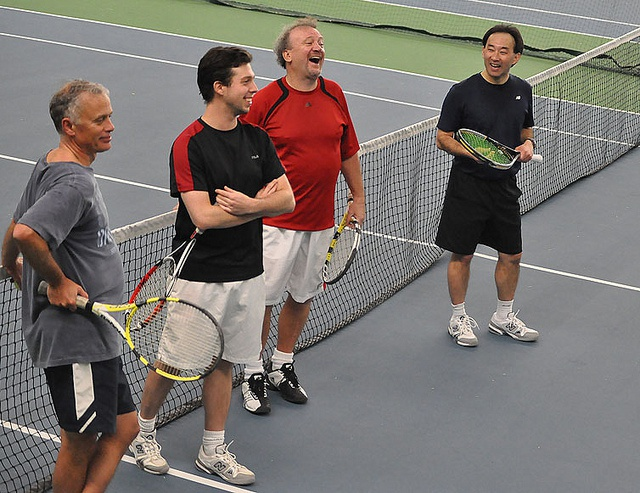Describe the objects in this image and their specific colors. I can see people in gray, black, darkgray, tan, and brown tones, people in gray, black, maroon, and darkgray tones, people in gray, black, darkgray, and brown tones, people in gray, brown, maroon, darkgray, and black tones, and tennis racket in gray, darkgray, tan, and black tones in this image. 